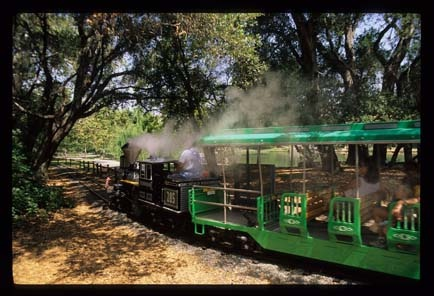Describe the objects in this image and their specific colors. I can see train in black, darkgreen, and gray tones, bench in black, darkgreen, and maroon tones, bench in black and darkgreen tones, bench in black and darkgreen tones, and people in black, gray, and maroon tones in this image. 